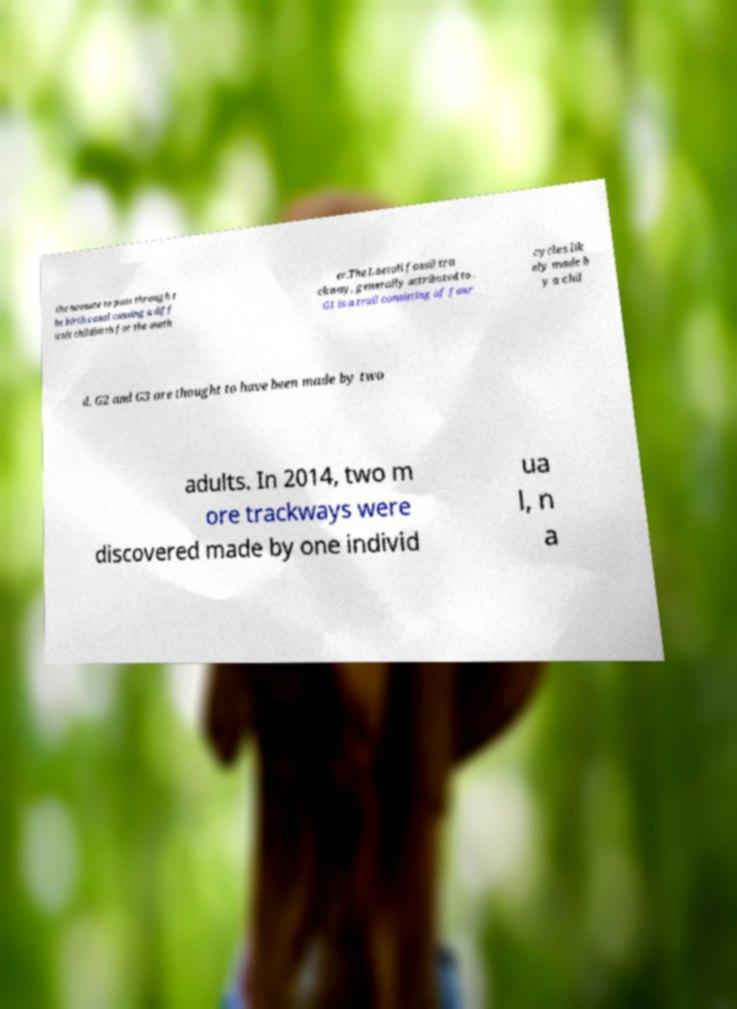Please read and relay the text visible in this image. What does it say? the neonate to pass through t he birth canal causing a diff icult childbirth for the moth er.The Laetoli fossil tra ckway, generally attributed to . G1 is a trail consisting of four cycles lik ely made b y a chil d. G2 and G3 are thought to have been made by two adults. In 2014, two m ore trackways were discovered made by one individ ua l, n a 